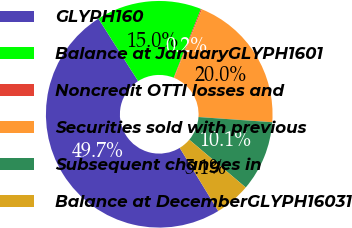<chart> <loc_0><loc_0><loc_500><loc_500><pie_chart><fcel>GLYPH160<fcel>Balance at JanuaryGLYPH1601<fcel>Noncredit OTTI losses and<fcel>Securities sold with previous<fcel>Subsequent changes in<fcel>Balance at DecemberGLYPH16031<nl><fcel>49.7%<fcel>15.01%<fcel>0.15%<fcel>19.97%<fcel>10.06%<fcel>5.1%<nl></chart> 